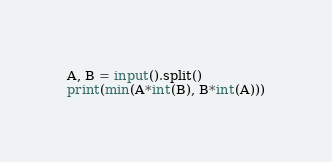<code> <loc_0><loc_0><loc_500><loc_500><_Python_>A, B = input().split()
print(min(A*int(B), B*int(A)))</code> 